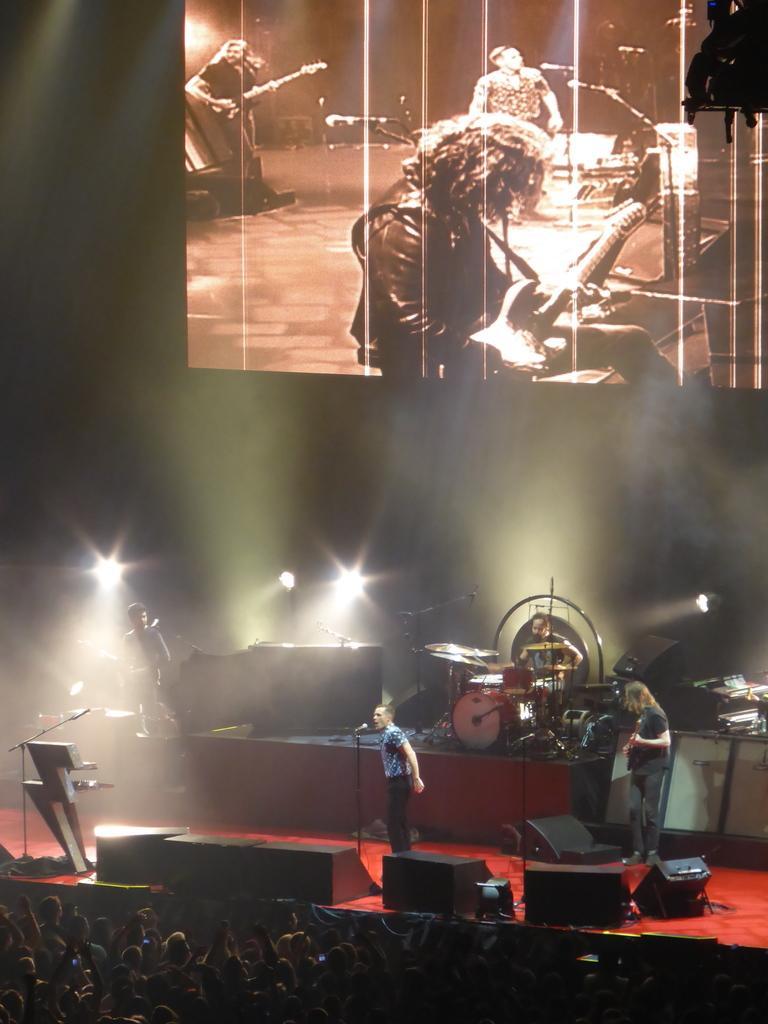Can you describe this image briefly? There is a stage. On the stage there are speakers, mic with stands, musical instruments, two people are standing. In the back there is a screen. There are lights. In front of the stage there is a crowd. 